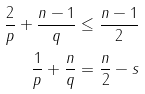<formula> <loc_0><loc_0><loc_500><loc_500>\frac { 2 } { p } + \frac { n - 1 } { q } & \leq \frac { n - 1 } { 2 } \\ \frac { 1 } { p } + \frac { n } { q } & = \frac { n } { 2 } - s</formula> 